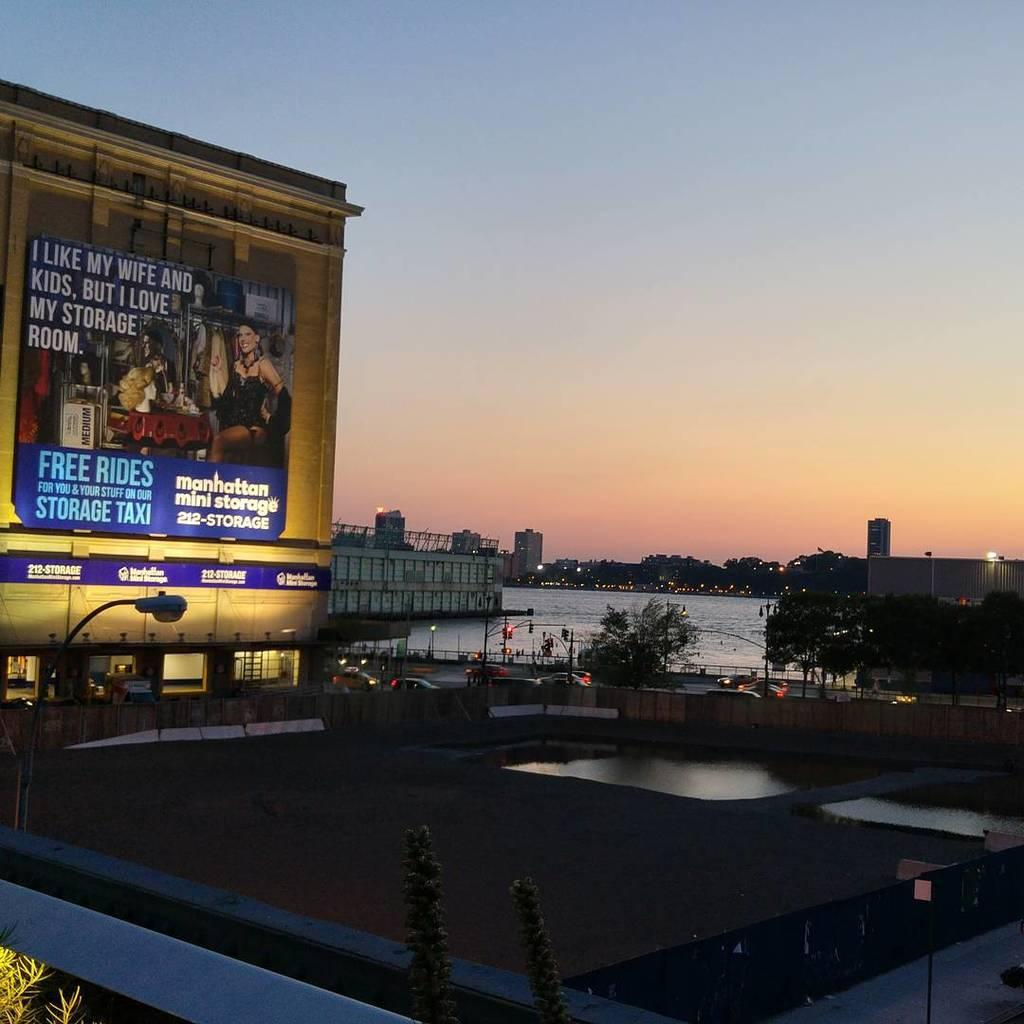<image>
Write a terse but informative summary of the picture. A view of the city with a large billboard advertising Manhattan Mini Storage. 